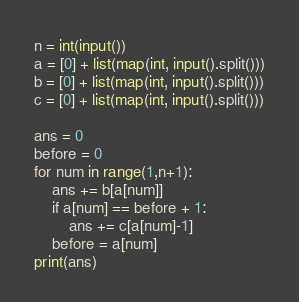<code> <loc_0><loc_0><loc_500><loc_500><_Python_>n = int(input())
a = [0] + list(map(int, input().split()))
b = [0] + list(map(int, input().split()))
c = [0] + list(map(int, input().split()))

ans = 0
before = 0
for num in range(1,n+1):
    ans += b[a[num]]
    if a[num] == before + 1:
        ans += c[a[num]-1]
    before = a[num]
print(ans)</code> 